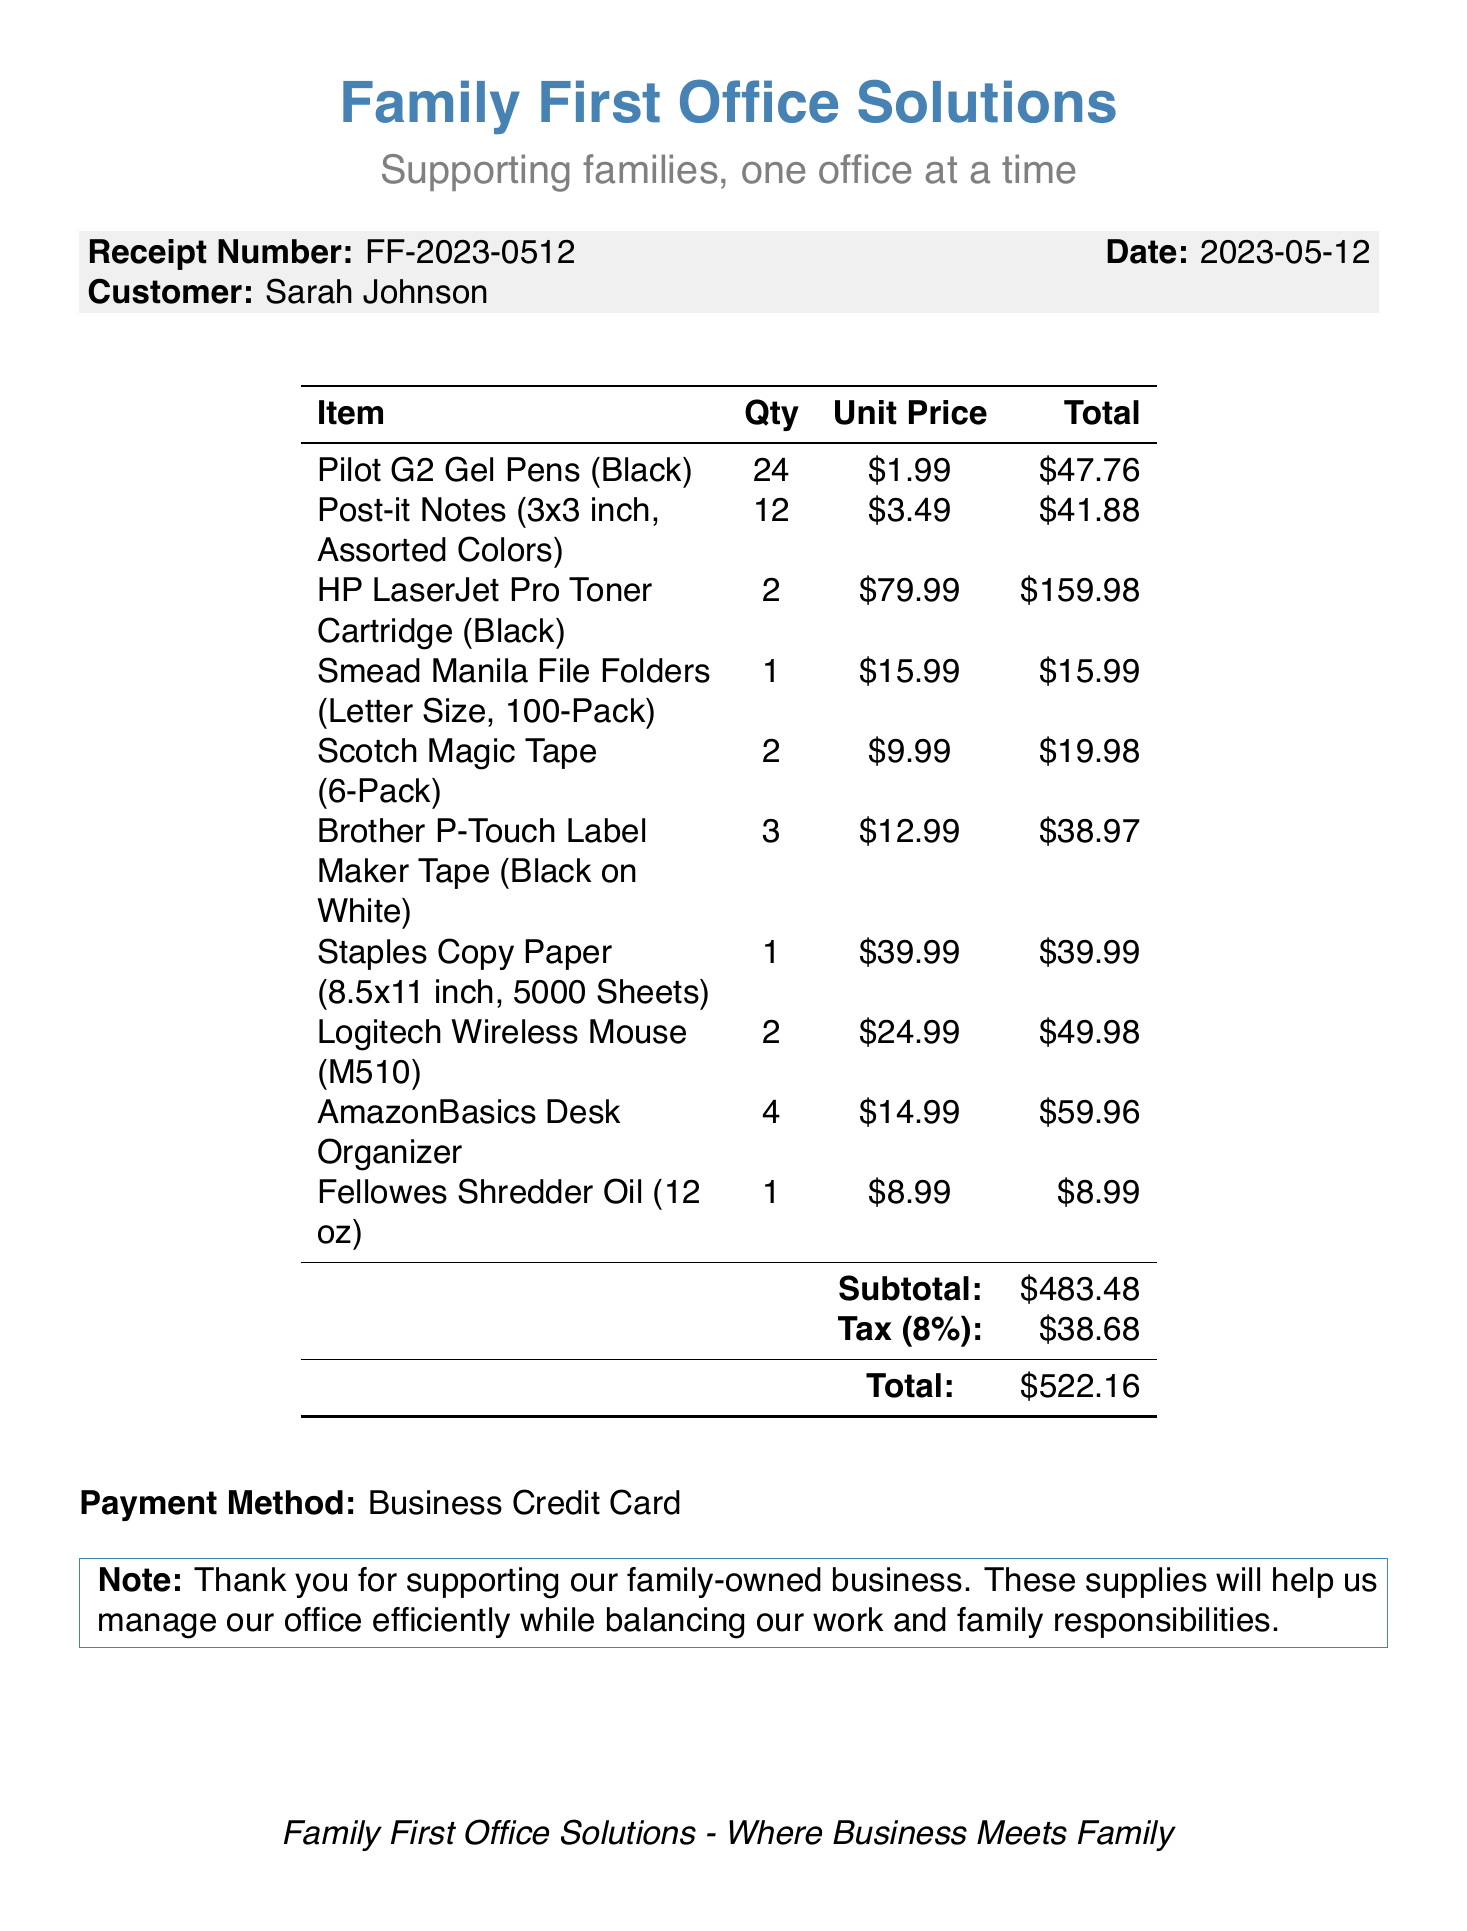What is the business name? The business name is stated at the top of the document.
Answer: Family First Office Solutions What is the receipt number? The receipt number is provided in the header section of the document.
Answer: FF-2023-0512 Who is the customer? The customer's name is specified in the document.
Answer: Sarah Johnson What is the subtotal amount? The subtotal amount is calculated before tax and is listed in the totals section of the document.
Answer: $483.48 How many items are listed on the receipt? The number of items is determined by counting the line items in the document.
Answer: 10 What is the tax rate applied? The tax rate is indicated in the totals section and is expressed as a percentage.
Answer: 8% What is the payment method used? The payment method is recorded at the bottom of the document.
Answer: Business Credit Card What is the total amount due? The total amount is the final figure provided in the totals section of the document.
Answer: $522.16 How many Pilot G2 Gel Pens were purchased? The quantity of Pilot G2 Gel Pens is provided in the itemized list.
Answer: 24 What does the note at the bottom of the receipt convey? The note expresses appreciation and the purpose of the supplies purchased.
Answer: Thank you for supporting our family-owned business 